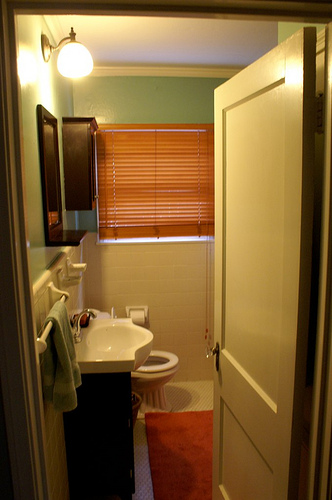How many knobs are present in the image? There are three knobs in the image: one on the cabinet door, one on the toilet handle, and another on the sink faucet. 